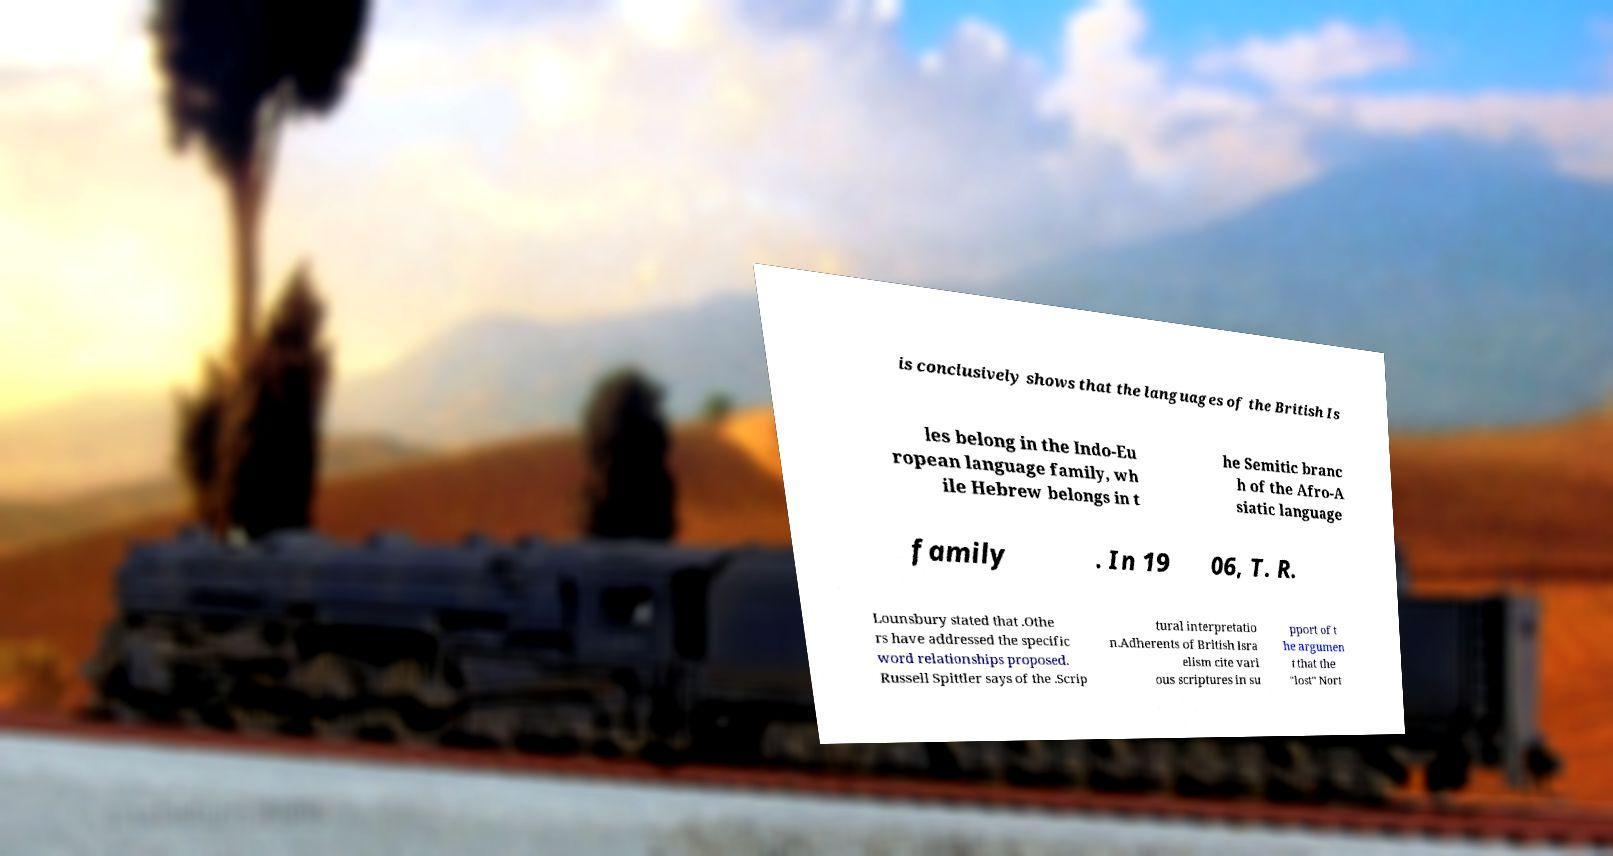Could you extract and type out the text from this image? is conclusively shows that the languages of the British Is les belong in the Indo-Eu ropean language family, wh ile Hebrew belongs in t he Semitic branc h of the Afro-A siatic language family . In 19 06, T. R. Lounsbury stated that .Othe rs have addressed the specific word relationships proposed. Russell Spittler says of the .Scrip tural interpretatio n.Adherents of British Isra elism cite vari ous scriptures in su pport of t he argumen t that the "lost" Nort 